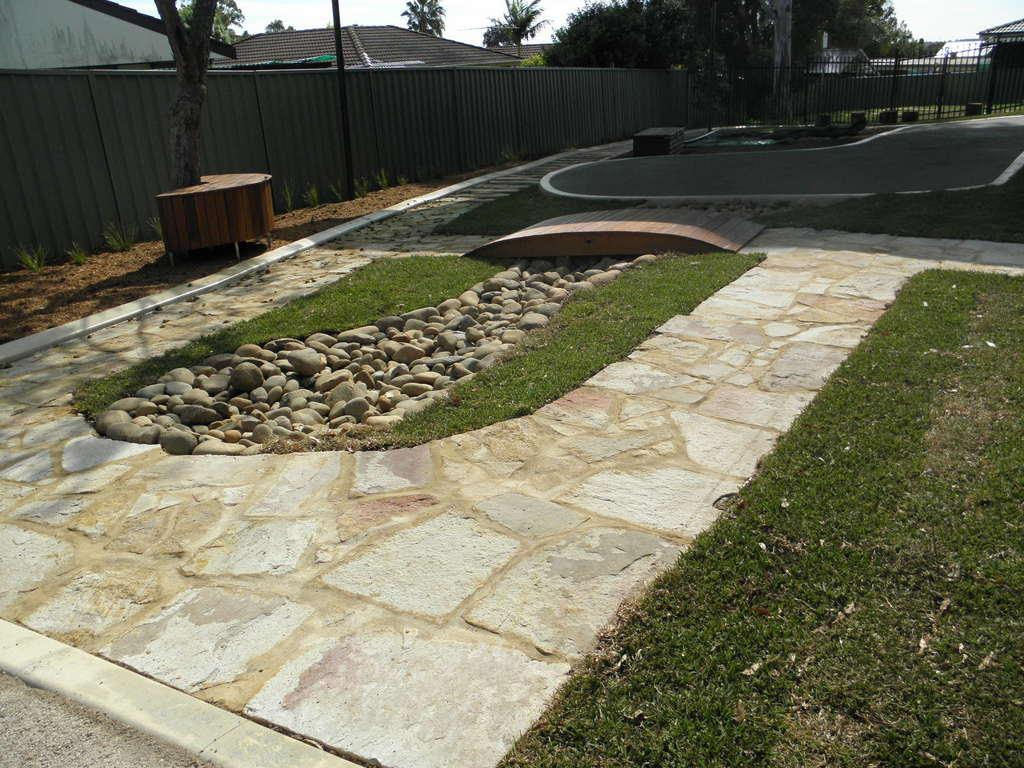What type of barrier can be seen in the image? There is a metal fence in the image. What natural elements are present in the image? There is a group of trees in the image. What man-made structures can be seen in the image? There are buildings in the image. What vertical object is present in the image? There is a pole in the image. What type of seating is available in the image? A bench is placed on the ground in the image. What can be seen in the background of the image? The sky is visible in the background of the image. What type of idea is depicted in the image? There is no idea depicted in the image; it contains a metal fence, a group of trees, buildings, a pole, a bench, and the sky. Can you see a beetle crawling on the bench in the image? There is no beetle present in the image; it only shows a bench, not any insects. 